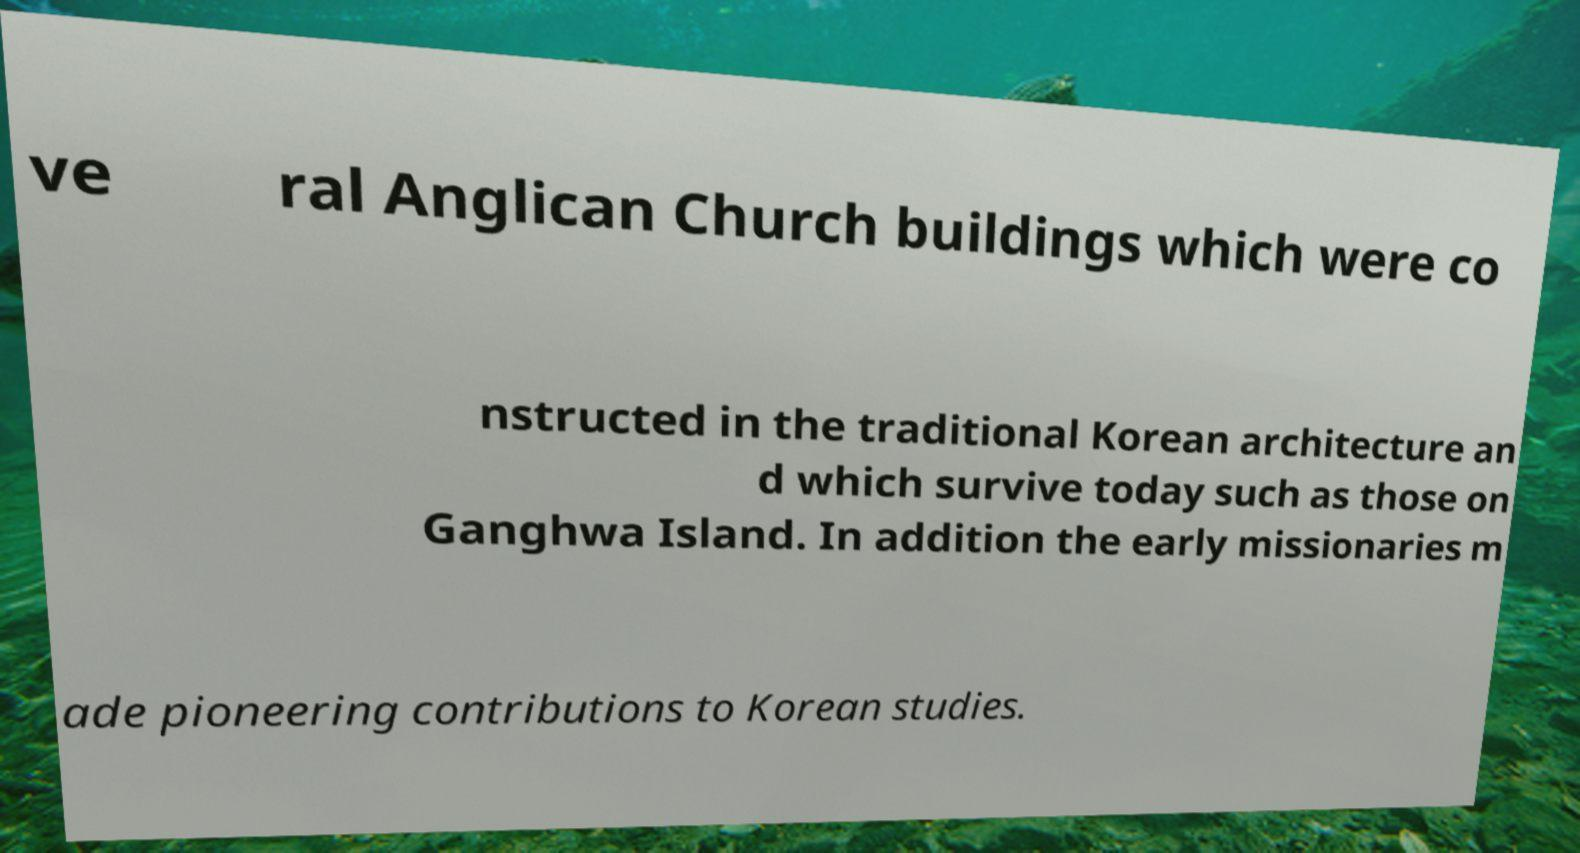There's text embedded in this image that I need extracted. Can you transcribe it verbatim? ve ral Anglican Church buildings which were co nstructed in the traditional Korean architecture an d which survive today such as those on Ganghwa Island. In addition the early missionaries m ade pioneering contributions to Korean studies. 